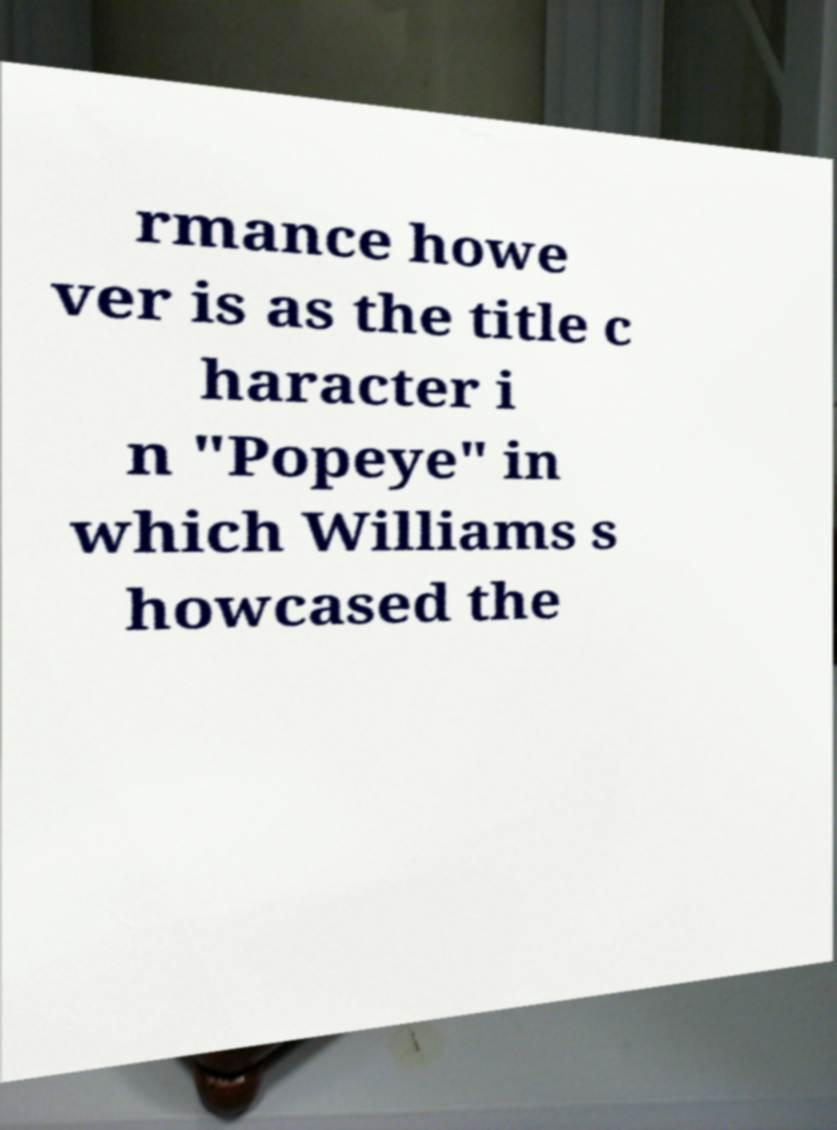For documentation purposes, I need the text within this image transcribed. Could you provide that? rmance howe ver is as the title c haracter i n "Popeye" in which Williams s howcased the 